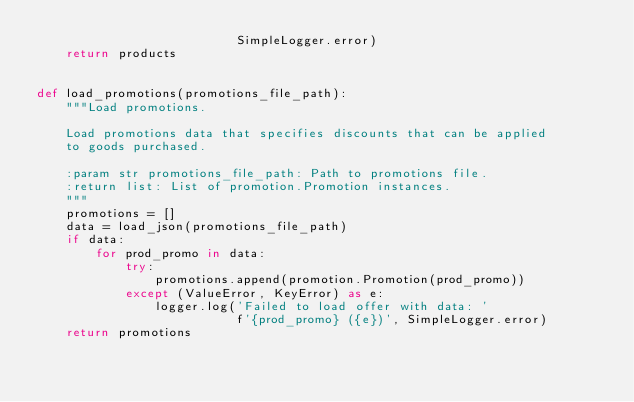<code> <loc_0><loc_0><loc_500><loc_500><_Python_>                           SimpleLogger.error)
    return products


def load_promotions(promotions_file_path):
    """Load promotions.

    Load promotions data that specifies discounts that can be applied
    to goods purchased.

    :param str promotions_file_path: Path to promotions file.
    :return list: List of promotion.Promotion instances.
    """
    promotions = []
    data = load_json(promotions_file_path)
    if data:
        for prod_promo in data:
            try:
                promotions.append(promotion.Promotion(prod_promo))
            except (ValueError, KeyError) as e:
                logger.log('Failed to load offer with data: '
                           f'{prod_promo} ({e})', SimpleLogger.error)
    return promotions
</code> 